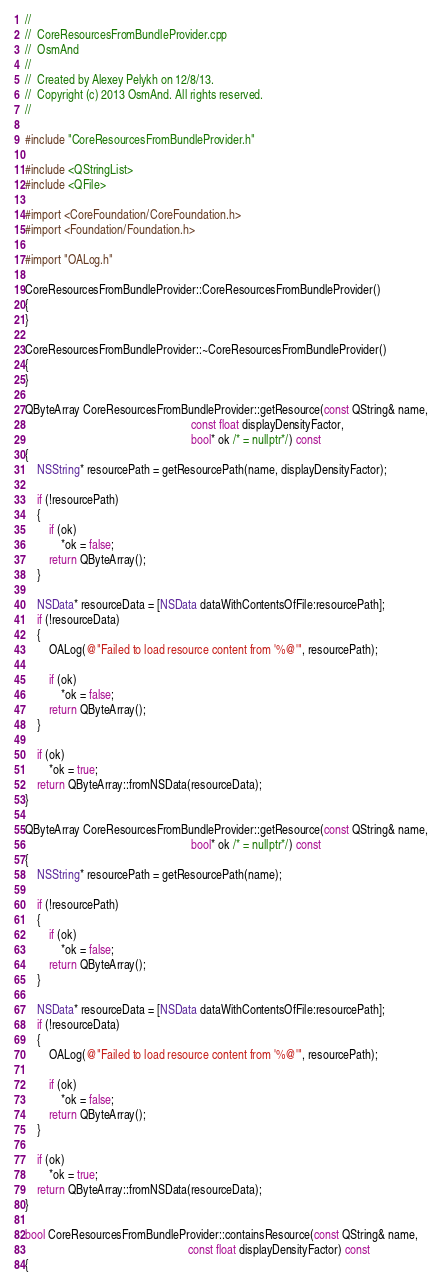<code> <loc_0><loc_0><loc_500><loc_500><_ObjectiveC_>//
//  CoreResourcesFromBundleProvider.cpp
//  OsmAnd
//
//  Created by Alexey Pelykh on 12/8/13.
//  Copyright (c) 2013 OsmAnd. All rights reserved.
//

#include "CoreResourcesFromBundleProvider.h"

#include <QStringList>
#include <QFile>

#import <CoreFoundation/CoreFoundation.h>
#import <Foundation/Foundation.h>

#import "OALog.h"

CoreResourcesFromBundleProvider::CoreResourcesFromBundleProvider()
{
}

CoreResourcesFromBundleProvider::~CoreResourcesFromBundleProvider()
{
}

QByteArray CoreResourcesFromBundleProvider::getResource(const QString& name,
                                                        const float displayDensityFactor,
                                                        bool* ok /* = nullptr*/) const
{
    NSString* resourcePath = getResourcePath(name, displayDensityFactor);

    if (!resourcePath)
    {
        if (ok)
            *ok = false;
        return QByteArray();
    }

    NSData* resourceData = [NSData dataWithContentsOfFile:resourcePath];
    if (!resourceData)
    {
        OALog(@"Failed to load resource content from '%@'", resourcePath);

        if (ok)
            *ok = false;
        return QByteArray();
    }

    if (ok)
        *ok = true;
    return QByteArray::fromNSData(resourceData);
}

QByteArray CoreResourcesFromBundleProvider::getResource(const QString& name,
                                                        bool* ok /* = nullptr*/) const
{
    NSString* resourcePath = getResourcePath(name);

    if (!resourcePath)
    {
        if (ok)
            *ok = false;
        return QByteArray();
    }

    NSData* resourceData = [NSData dataWithContentsOfFile:resourcePath];
    if (!resourceData)
    {
        OALog(@"Failed to load resource content from '%@'", resourcePath);

        if (ok)
            *ok = false;
        return QByteArray();
    }

    if (ok)
        *ok = true;
    return QByteArray::fromNSData(resourceData);
}

bool CoreResourcesFromBundleProvider::containsResource(const QString& name,
                                                       const float displayDensityFactor) const
{</code> 